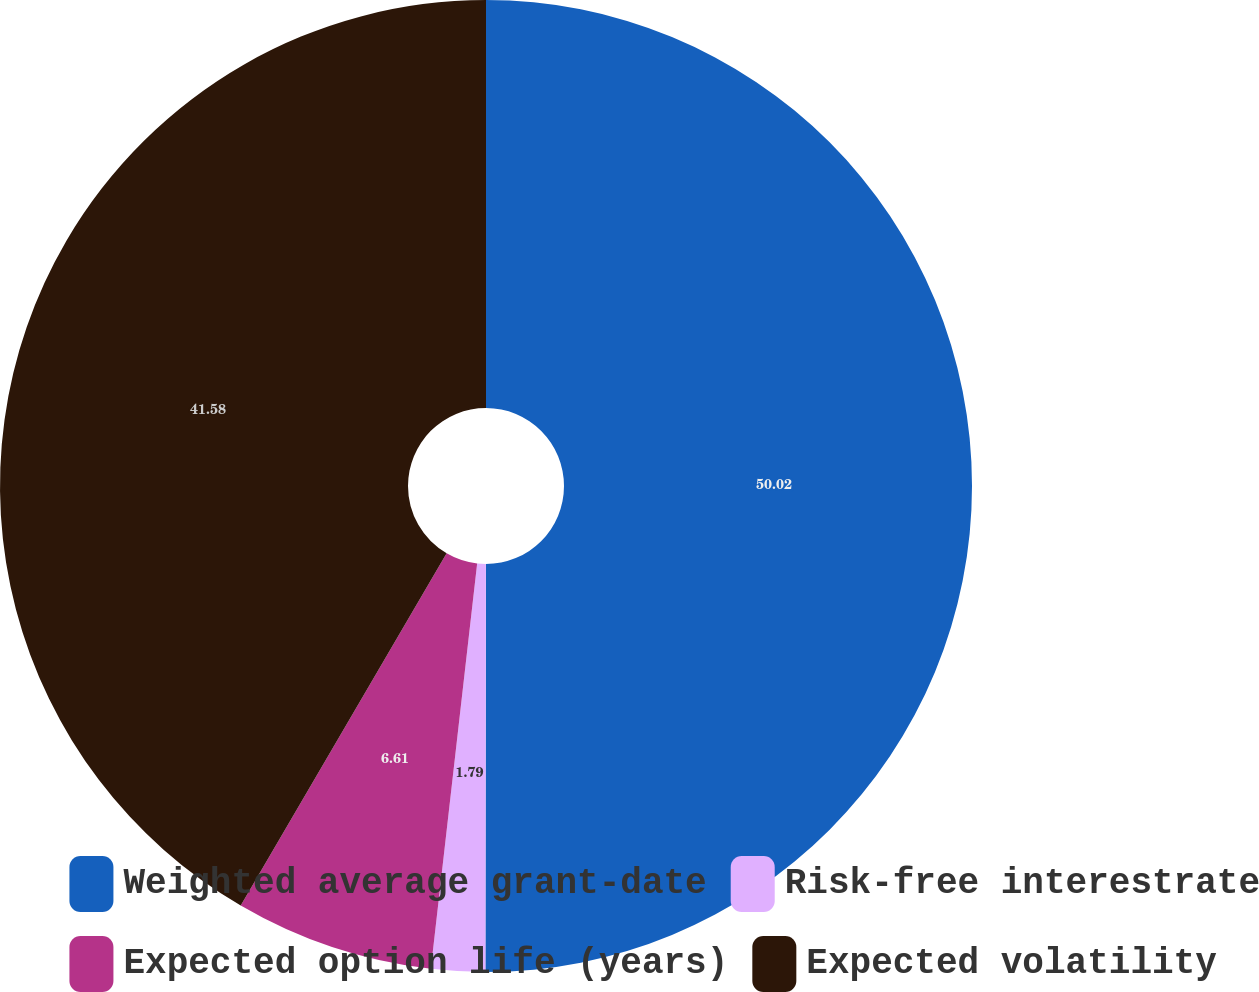<chart> <loc_0><loc_0><loc_500><loc_500><pie_chart><fcel>Weighted average grant-date<fcel>Risk-free interestrate<fcel>Expected option life (years)<fcel>Expected volatility<nl><fcel>50.02%<fcel>1.79%<fcel>6.61%<fcel>41.58%<nl></chart> 